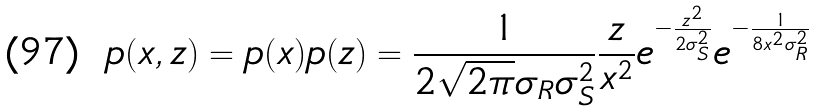Convert formula to latex. <formula><loc_0><loc_0><loc_500><loc_500>p ( x , z ) = p ( x ) p ( z ) = \frac { 1 } { 2 \sqrt { 2 \pi } \sigma _ { R } \sigma ^ { 2 } _ { S } } \frac { z } { x ^ { 2 } } e ^ { - \frac { z ^ { 2 } } { 2 \sigma ^ { 2 } _ { S } } } e ^ { - \frac { 1 } { 8 x ^ { 2 } \sigma ^ { 2 } _ { R } } }</formula> 